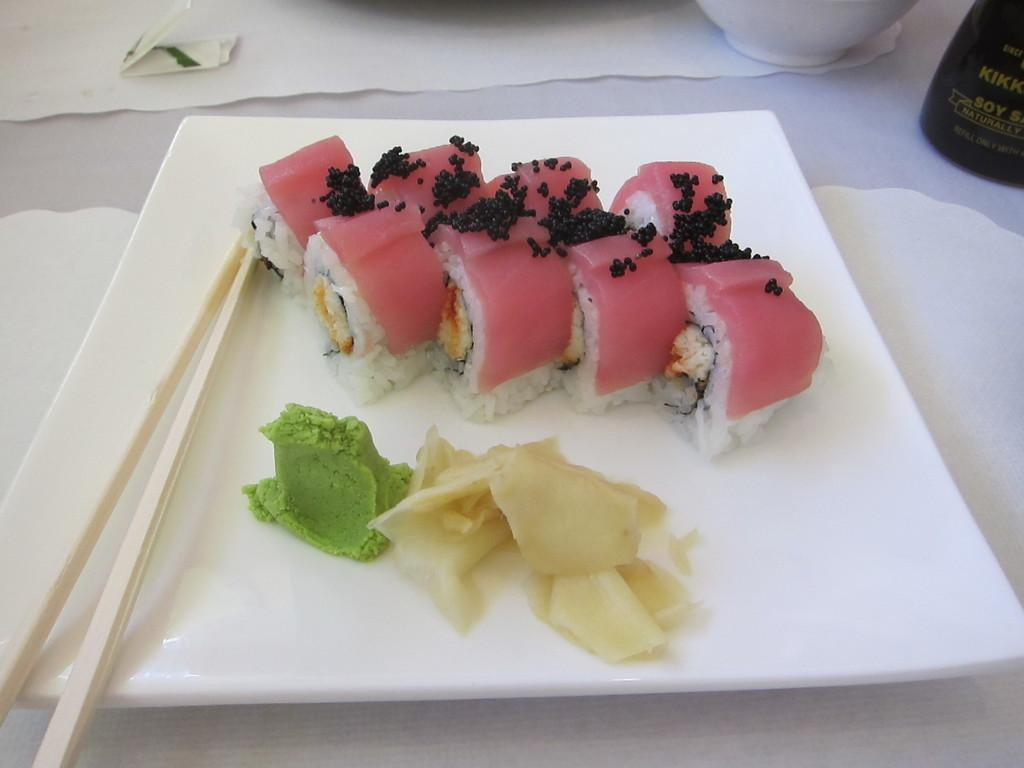What is on the plate in the image? There is food and chopsticks on a plate in the image. Where is the plate located? The plate is placed on a surface. What can be seen in the background of the image? There is a bottle, a bowl, and a paper in the background of the image. Where are the objects in the background placed? The objects in the background are placed on a table. What type of canvas is the queen using to paint in the image? There is no canvas or queen present in the image. How does the wrist of the person holding the chopsticks look in the image? There is no visible wrist of a person holding chopsticks in the image. 